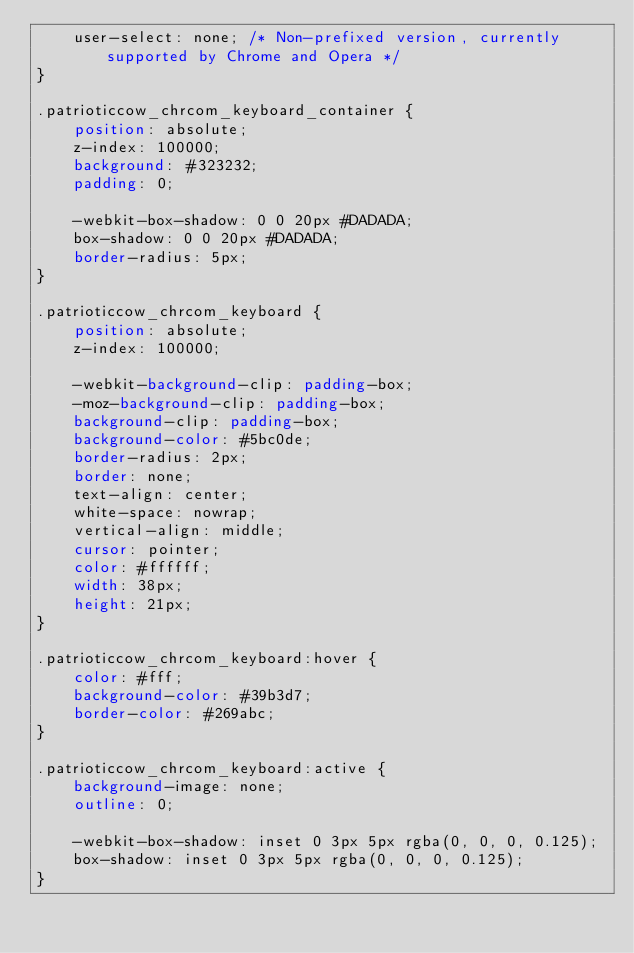Convert code to text. <code><loc_0><loc_0><loc_500><loc_500><_CSS_>    user-select: none; /* Non-prefixed version, currently supported by Chrome and Opera */
}

.patrioticcow_chrcom_keyboard_container {
    position: absolute;
    z-index: 100000;
    background: #323232;
    padding: 0;

    -webkit-box-shadow: 0 0 20px #DADADA;
    box-shadow: 0 0 20px #DADADA;
    border-radius: 5px;
}

.patrioticcow_chrcom_keyboard {
    position: absolute;
    z-index: 100000;

    -webkit-background-clip: padding-box;
    -moz-background-clip: padding-box;
    background-clip: padding-box;
    background-color: #5bc0de;
    border-radius: 2px;
    border: none;
    text-align: center;
    white-space: nowrap;
    vertical-align: middle;
    cursor: pointer;
    color: #ffffff;
    width: 38px;
    height: 21px;
}

.patrioticcow_chrcom_keyboard:hover {
    color: #fff;
    background-color: #39b3d7;
    border-color: #269abc;
}

.patrioticcow_chrcom_keyboard:active {
    background-image: none;
    outline: 0;

    -webkit-box-shadow: inset 0 3px 5px rgba(0, 0, 0, 0.125);
    box-shadow: inset 0 3px 5px rgba(0, 0, 0, 0.125);
}
</code> 